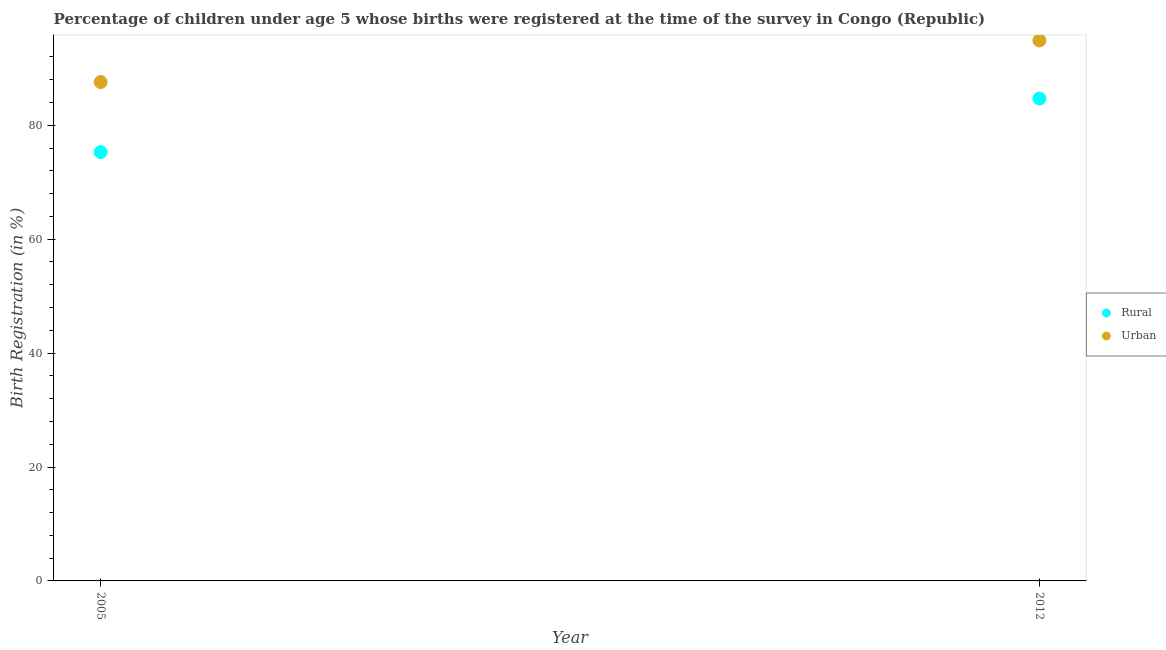Is the number of dotlines equal to the number of legend labels?
Offer a terse response. Yes. What is the urban birth registration in 2005?
Ensure brevity in your answer.  87.6. Across all years, what is the maximum urban birth registration?
Your answer should be very brief. 94.9. Across all years, what is the minimum rural birth registration?
Ensure brevity in your answer.  75.3. In which year was the urban birth registration maximum?
Provide a succinct answer. 2012. What is the total rural birth registration in the graph?
Make the answer very short. 160. What is the difference between the urban birth registration in 2005 and that in 2012?
Your answer should be compact. -7.3. What is the difference between the rural birth registration in 2012 and the urban birth registration in 2005?
Keep it short and to the point. -2.9. In the year 2012, what is the difference between the urban birth registration and rural birth registration?
Your response must be concise. 10.2. What is the ratio of the rural birth registration in 2005 to that in 2012?
Your response must be concise. 0.89. Is the urban birth registration in 2005 less than that in 2012?
Provide a short and direct response. Yes. In how many years, is the urban birth registration greater than the average urban birth registration taken over all years?
Make the answer very short. 1. How many dotlines are there?
Your answer should be very brief. 2. Are the values on the major ticks of Y-axis written in scientific E-notation?
Your answer should be very brief. No. Does the graph contain any zero values?
Provide a short and direct response. No. Does the graph contain grids?
Give a very brief answer. No. How many legend labels are there?
Your answer should be compact. 2. How are the legend labels stacked?
Offer a very short reply. Vertical. What is the title of the graph?
Offer a terse response. Percentage of children under age 5 whose births were registered at the time of the survey in Congo (Republic). Does "Transport services" appear as one of the legend labels in the graph?
Offer a very short reply. No. What is the label or title of the Y-axis?
Give a very brief answer. Birth Registration (in %). What is the Birth Registration (in %) of Rural in 2005?
Ensure brevity in your answer.  75.3. What is the Birth Registration (in %) in Urban in 2005?
Make the answer very short. 87.6. What is the Birth Registration (in %) of Rural in 2012?
Your answer should be very brief. 84.7. What is the Birth Registration (in %) in Urban in 2012?
Your answer should be very brief. 94.9. Across all years, what is the maximum Birth Registration (in %) of Rural?
Ensure brevity in your answer.  84.7. Across all years, what is the maximum Birth Registration (in %) of Urban?
Offer a very short reply. 94.9. Across all years, what is the minimum Birth Registration (in %) in Rural?
Provide a succinct answer. 75.3. Across all years, what is the minimum Birth Registration (in %) of Urban?
Keep it short and to the point. 87.6. What is the total Birth Registration (in %) of Rural in the graph?
Make the answer very short. 160. What is the total Birth Registration (in %) of Urban in the graph?
Your answer should be very brief. 182.5. What is the difference between the Birth Registration (in %) in Urban in 2005 and that in 2012?
Provide a short and direct response. -7.3. What is the difference between the Birth Registration (in %) in Rural in 2005 and the Birth Registration (in %) in Urban in 2012?
Give a very brief answer. -19.6. What is the average Birth Registration (in %) of Rural per year?
Offer a very short reply. 80. What is the average Birth Registration (in %) in Urban per year?
Your answer should be very brief. 91.25. What is the ratio of the Birth Registration (in %) of Rural in 2005 to that in 2012?
Ensure brevity in your answer.  0.89. What is the ratio of the Birth Registration (in %) in Urban in 2005 to that in 2012?
Your response must be concise. 0.92. What is the difference between the highest and the second highest Birth Registration (in %) of Rural?
Your answer should be very brief. 9.4. What is the difference between the highest and the lowest Birth Registration (in %) in Rural?
Make the answer very short. 9.4. 